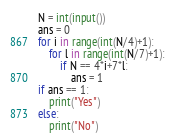<code> <loc_0><loc_0><loc_500><loc_500><_Python_>N = int(input())
ans = 0
for i in range(int(N/4)+1):
	for l in range(int(N/7)+1):
		if N == 4*i+7*l:
			ans = 1
if ans == 1:
	print("Yes")
else:
	print("No")</code> 